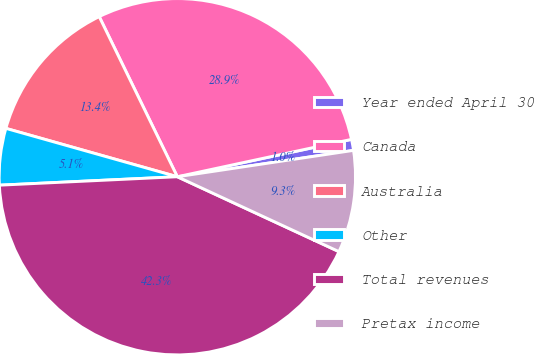<chart> <loc_0><loc_0><loc_500><loc_500><pie_chart><fcel>Year ended April 30<fcel>Canada<fcel>Australia<fcel>Other<fcel>Total revenues<fcel>Pretax income<nl><fcel>1.0%<fcel>28.86%<fcel>13.4%<fcel>5.13%<fcel>42.34%<fcel>9.27%<nl></chart> 